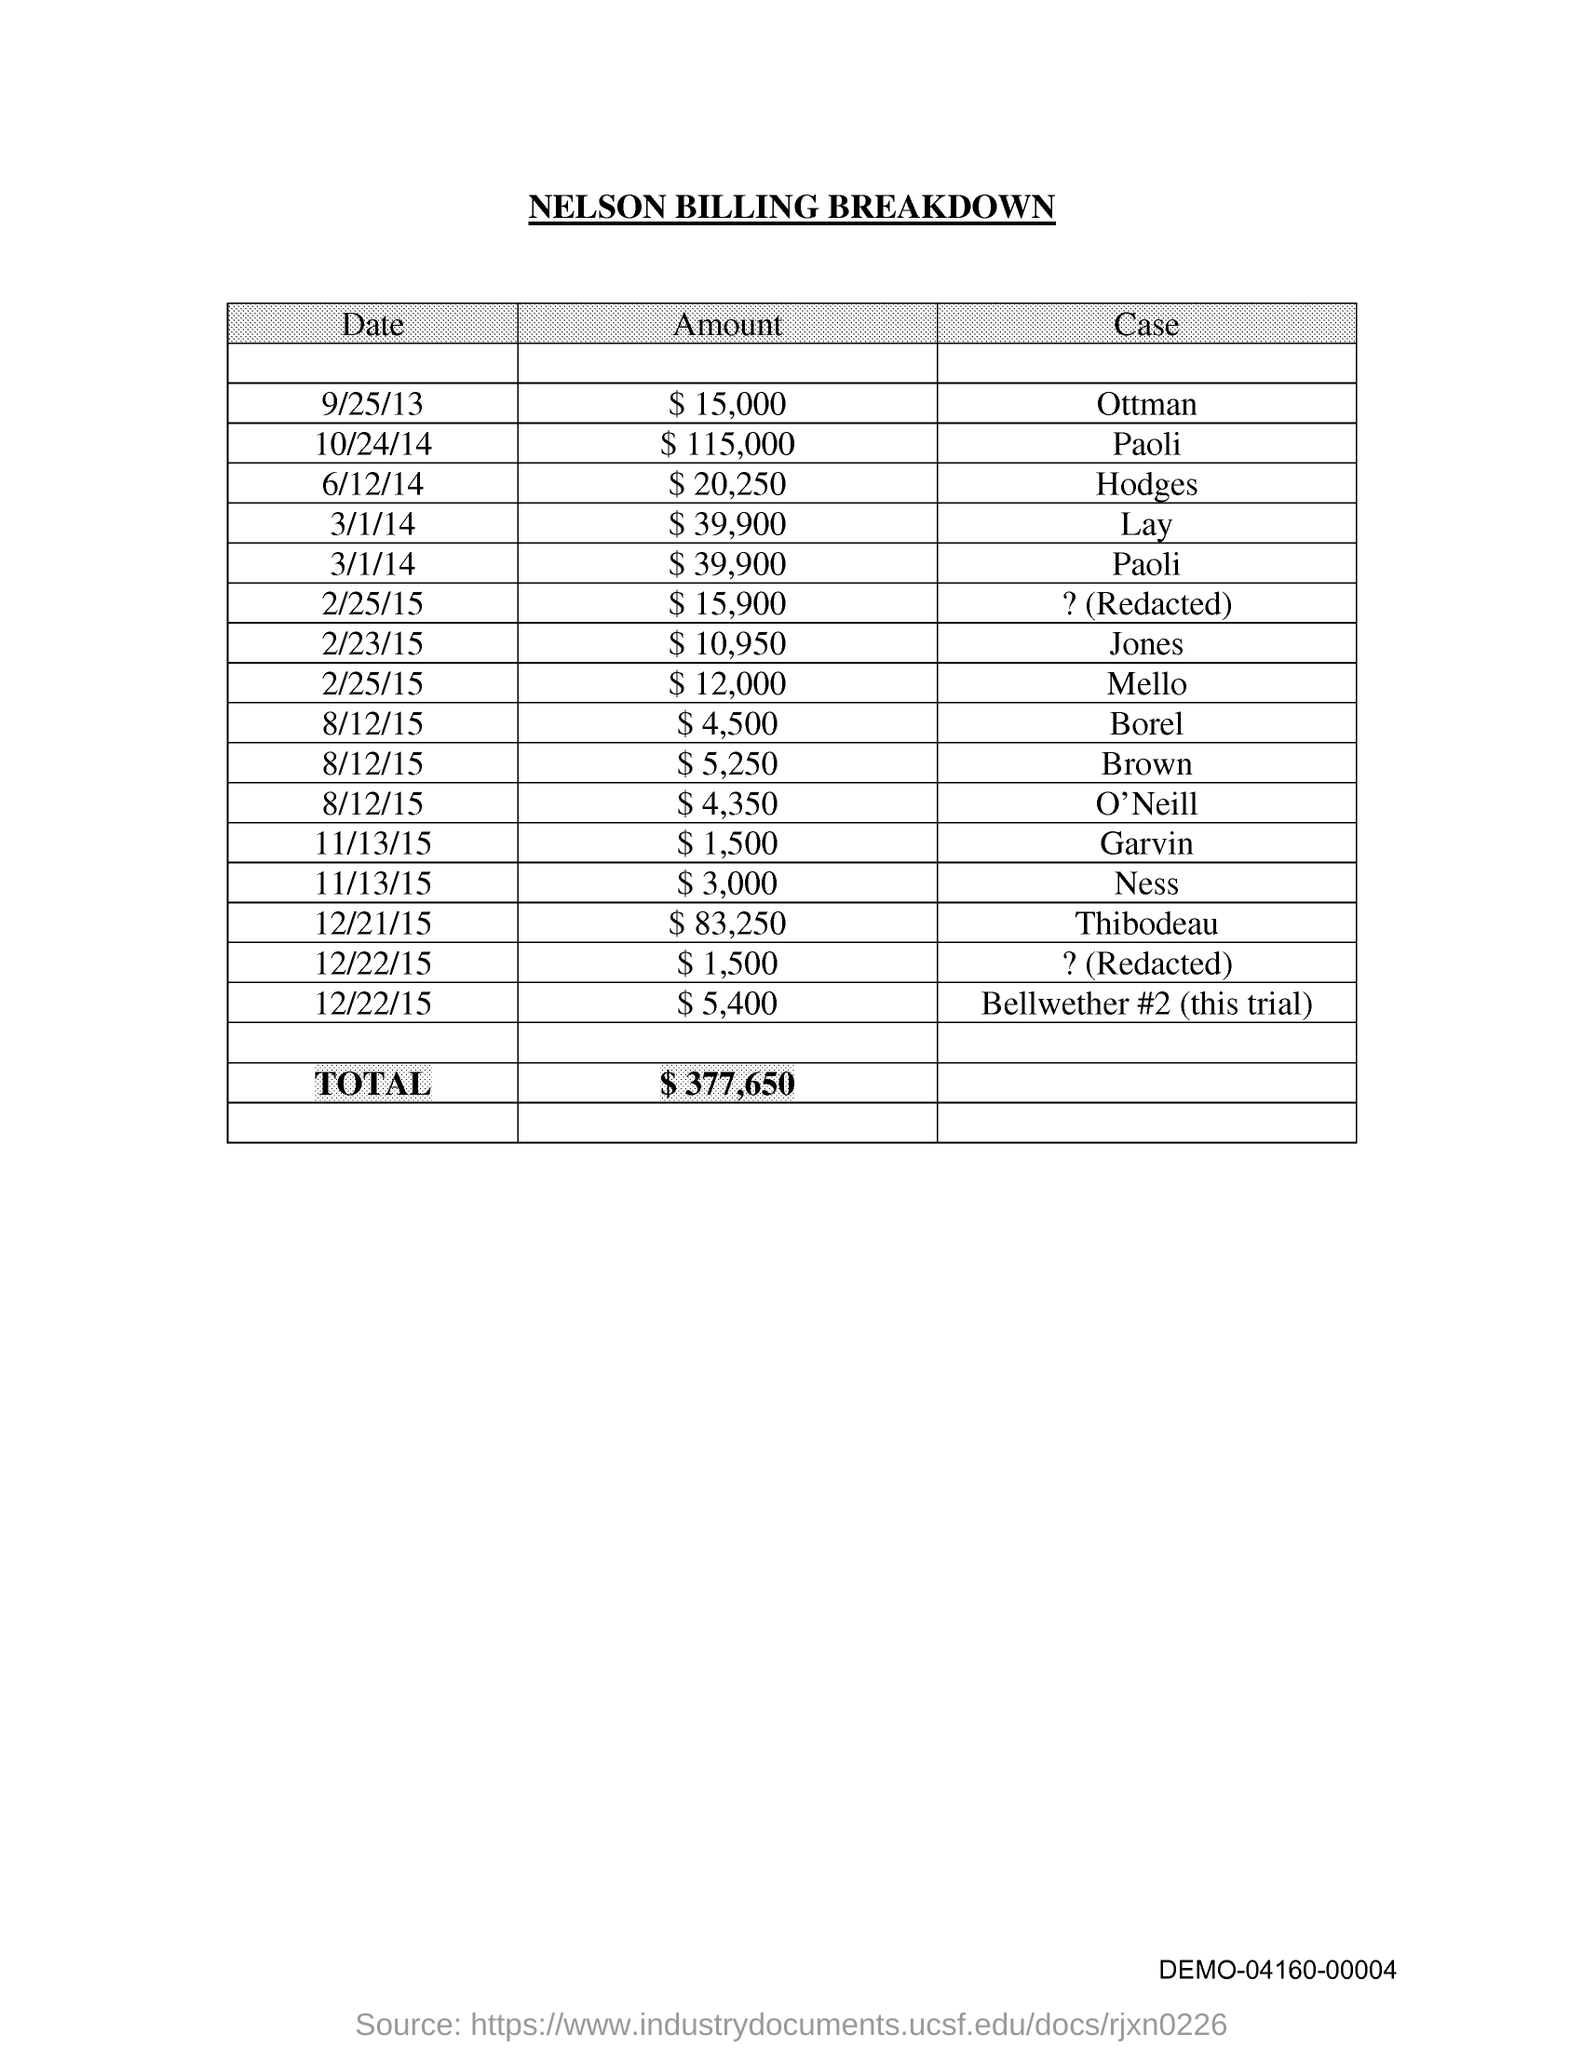Point out several critical features in this image. The total amount is $377,650. 